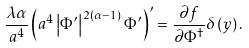Convert formula to latex. <formula><loc_0><loc_0><loc_500><loc_500>\frac { \lambda \alpha } { a ^ { 4 } } \left ( a ^ { 4 } \left | \Phi ^ { \prime } \right | ^ { 2 \left ( \alpha - 1 \right ) } \Phi ^ { \prime } \right ) ^ { \prime } = \frac { \partial f } { \partial \Phi ^ { \dagger } } \delta \left ( y \right ) .</formula> 